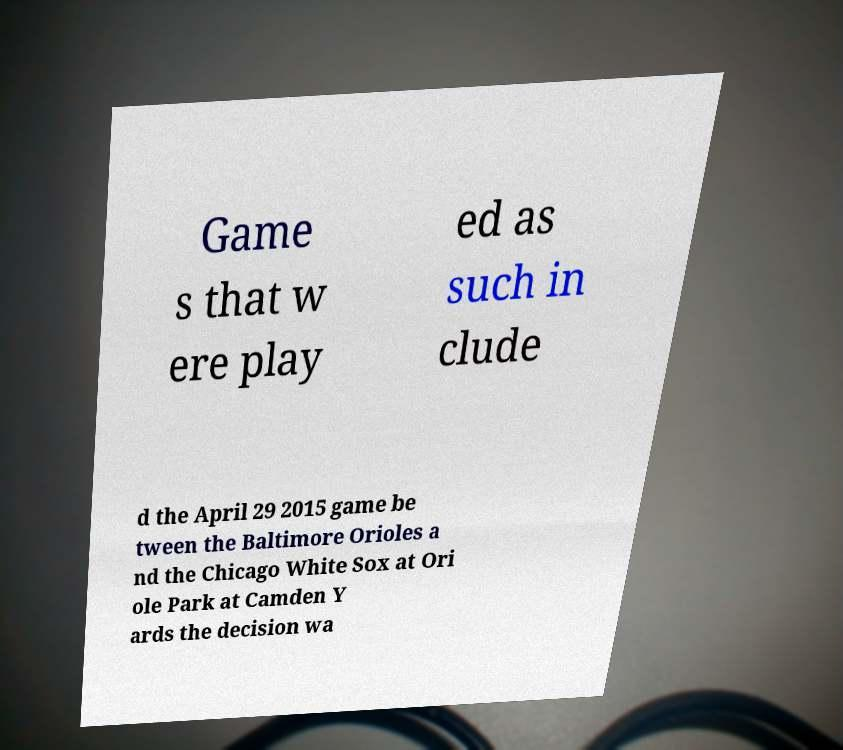Could you extract and type out the text from this image? Game s that w ere play ed as such in clude d the April 29 2015 game be tween the Baltimore Orioles a nd the Chicago White Sox at Ori ole Park at Camden Y ards the decision wa 